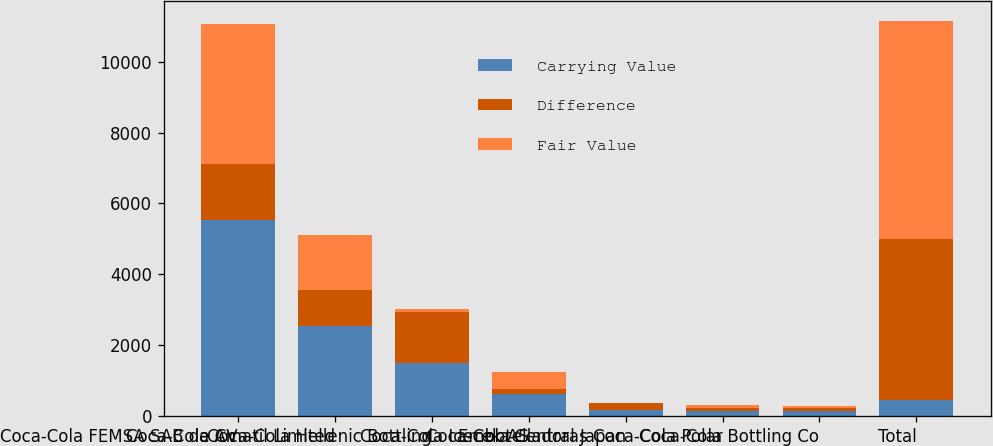Convert chart. <chart><loc_0><loc_0><loc_500><loc_500><stacked_bar_chart><ecel><fcel>Coca-Cola FEMSA SAB de CV<fcel>Coca-Cola Amatil Limited<fcel>Coca-Cola Hellenic Bottling<fcel>Coca-Cola Icecek AS<fcel>Coca-Cola Central Japan<fcel>Embotelladoras Coca-Cola Polar<fcel>Coca-Cola Bottling Co<fcel>Total<nl><fcel>Carrying Value<fcel>5532<fcel>2551<fcel>1506<fcel>622<fcel>183<fcel>154<fcel>145<fcel>467<nl><fcel>Difference<fcel>1569<fcel>999<fcel>1442<fcel>155<fcel>186<fcel>86<fcel>84<fcel>4521<nl><fcel>Fair Value<fcel>3963<fcel>1552<fcel>64<fcel>467<fcel>3<fcel>68<fcel>61<fcel>6172<nl></chart> 